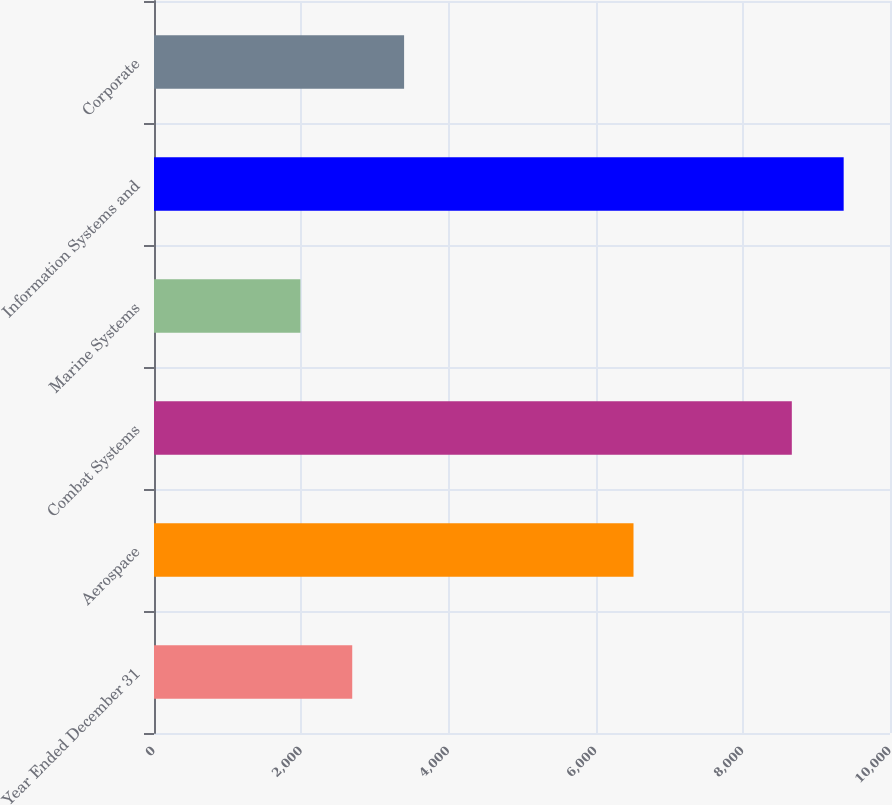Convert chart. <chart><loc_0><loc_0><loc_500><loc_500><bar_chart><fcel>Year Ended December 31<fcel>Aerospace<fcel>Combat Systems<fcel>Marine Systems<fcel>Information Systems and<fcel>Corporate<nl><fcel>2693.5<fcel>6515<fcel>8666<fcel>1989<fcel>9370.5<fcel>3398<nl></chart> 